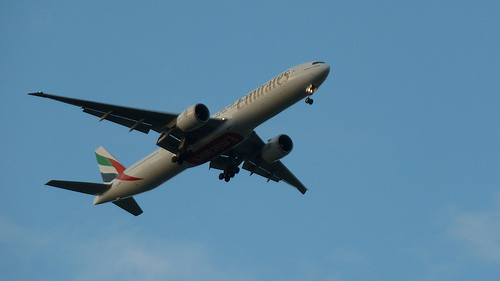Is there a ball in the air? No, there are no balls visible in the air in this particular image. 